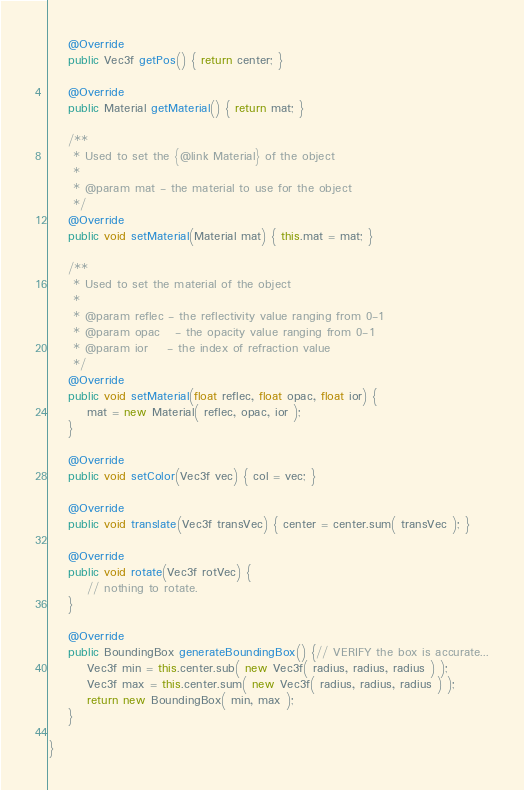Convert code to text. <code><loc_0><loc_0><loc_500><loc_500><_Java_>
	@Override
	public Vec3f getPos() { return center; }

	@Override
	public Material getMaterial() { return mat; }

	/**
	 * Used to set the {@link Material} of the object
	 * 
	 * @param mat - the material to use for the object
	 */
	@Override
	public void setMaterial(Material mat) { this.mat = mat; }

	/**
	 * Used to set the material of the object
	 * 
	 * @param reflec - the reflectivity value ranging from 0-1
	 * @param opac   - the opacity value ranging from 0-1
	 * @param ior    - the index of refraction value
	 */
	@Override
	public void setMaterial(float reflec, float opac, float ior) {
		mat = new Material( reflec, opac, ior );
	}

	@Override
	public void setColor(Vec3f vec) { col = vec; }

	@Override
	public void translate(Vec3f transVec) { center = center.sum( transVec ); }

	@Override
	public void rotate(Vec3f rotVec) {
		// nothing to rotate.
	}

	@Override
	public BoundingBox generateBoundingBox() {// VERIFY the box is accurate...
		Vec3f min = this.center.sub( new Vec3f( radius, radius, radius ) );
		Vec3f max = this.center.sum( new Vec3f( radius, radius, radius ) );
		return new BoundingBox( min, max );
	}

}
</code> 